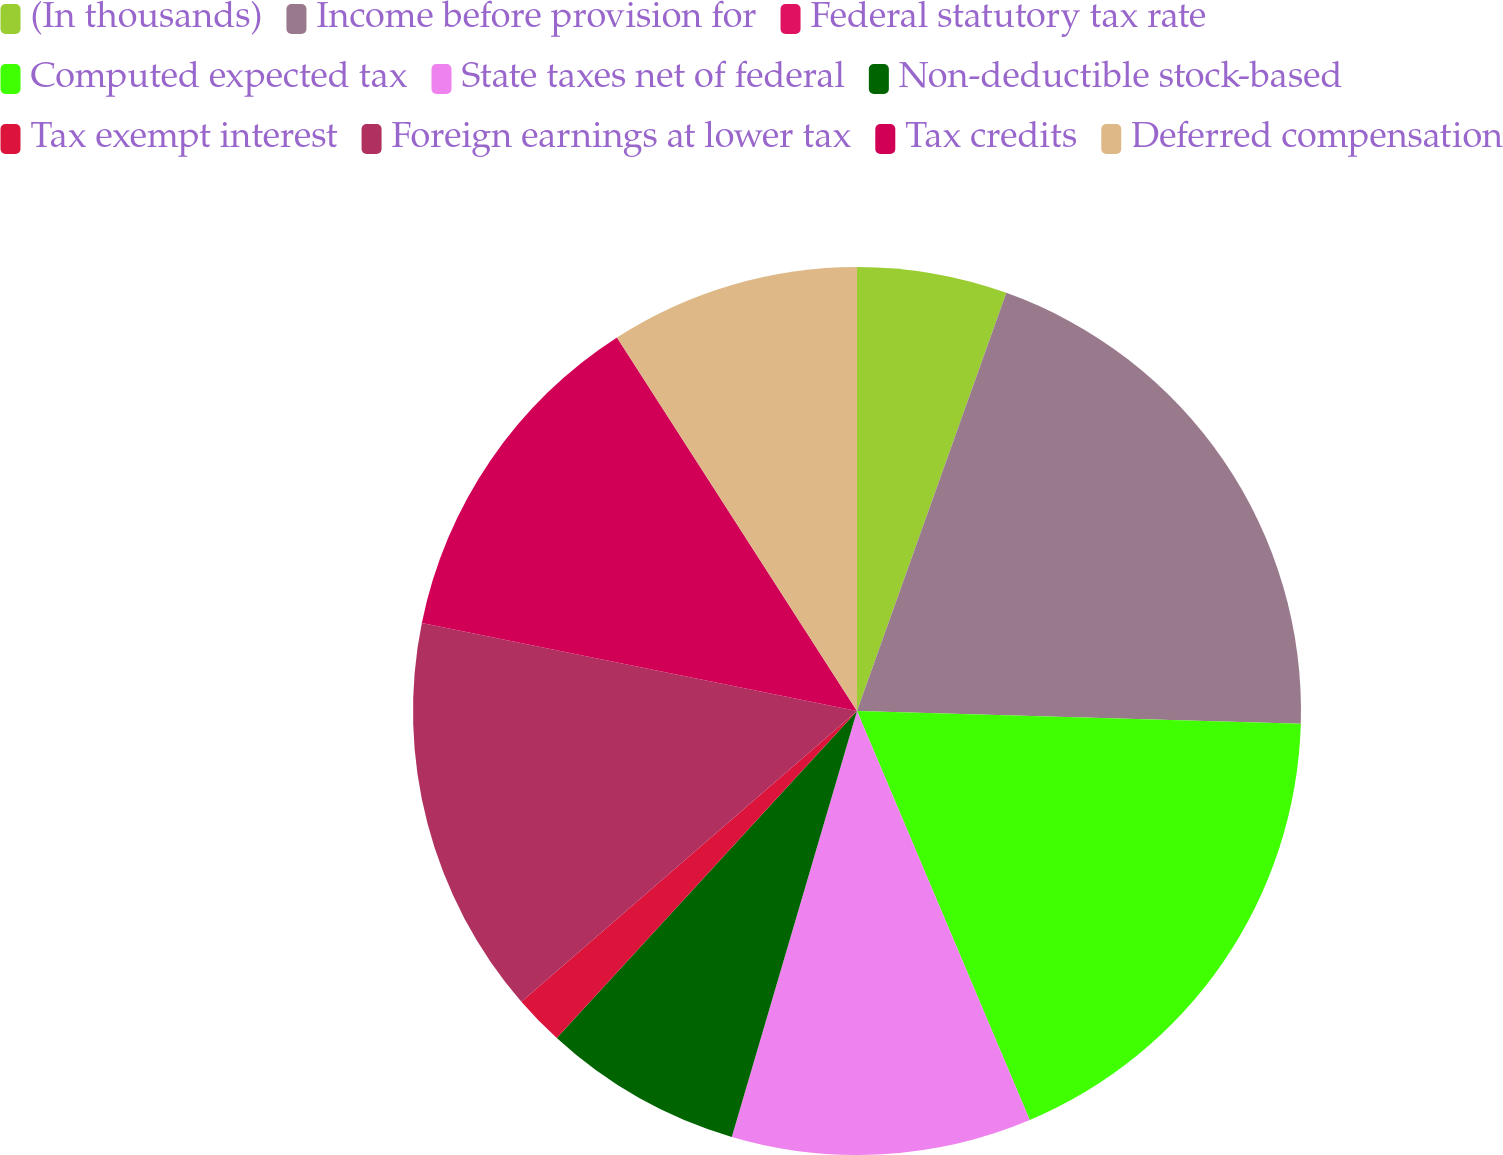Convert chart. <chart><loc_0><loc_0><loc_500><loc_500><pie_chart><fcel>(In thousands)<fcel>Income before provision for<fcel>Federal statutory tax rate<fcel>Computed expected tax<fcel>State taxes net of federal<fcel>Non-deductible stock-based<fcel>Tax exempt interest<fcel>Foreign earnings at lower tax<fcel>Tax credits<fcel>Deferred compensation<nl><fcel>5.46%<fcel>20.0%<fcel>0.0%<fcel>18.18%<fcel>10.91%<fcel>7.27%<fcel>1.82%<fcel>14.54%<fcel>12.73%<fcel>9.09%<nl></chart> 